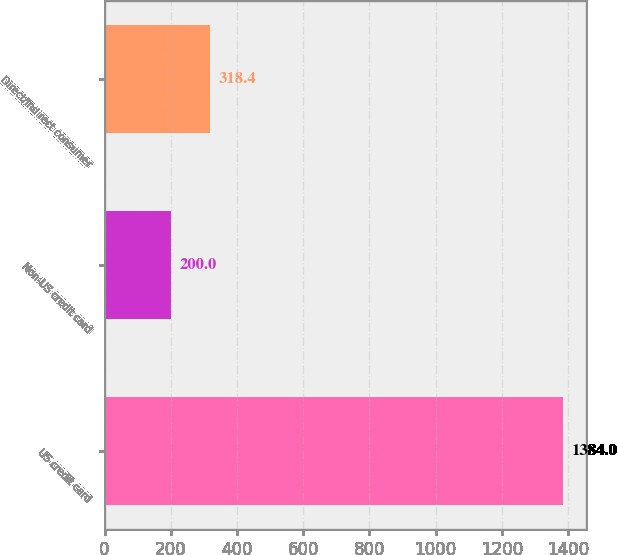Convert chart to OTSL. <chart><loc_0><loc_0><loc_500><loc_500><bar_chart><fcel>US credit card<fcel>Non-US credit card<fcel>Direct/Indirect consumer<nl><fcel>1384<fcel>200<fcel>318.4<nl></chart> 